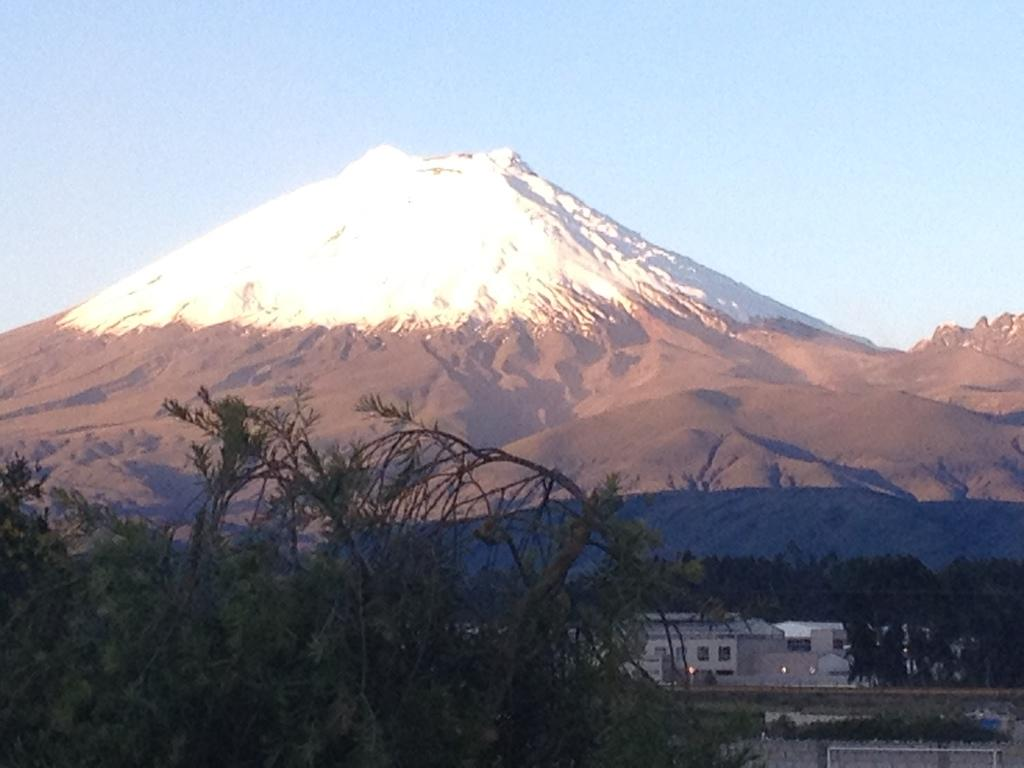What type of structures can be seen in the image? There are buildings in the image. What natural elements are present in the image? There are trees and plants in the image. What geographical feature is visible in the image? There are mountains in the image. What is the condition of the sky in the background of the image? The sky is clear in the background of the image. What type of oven can be seen in the image? There is no oven present in the image. What vein is visible in the image? There are no veins visible in the image; it features natural and man-made elements. 